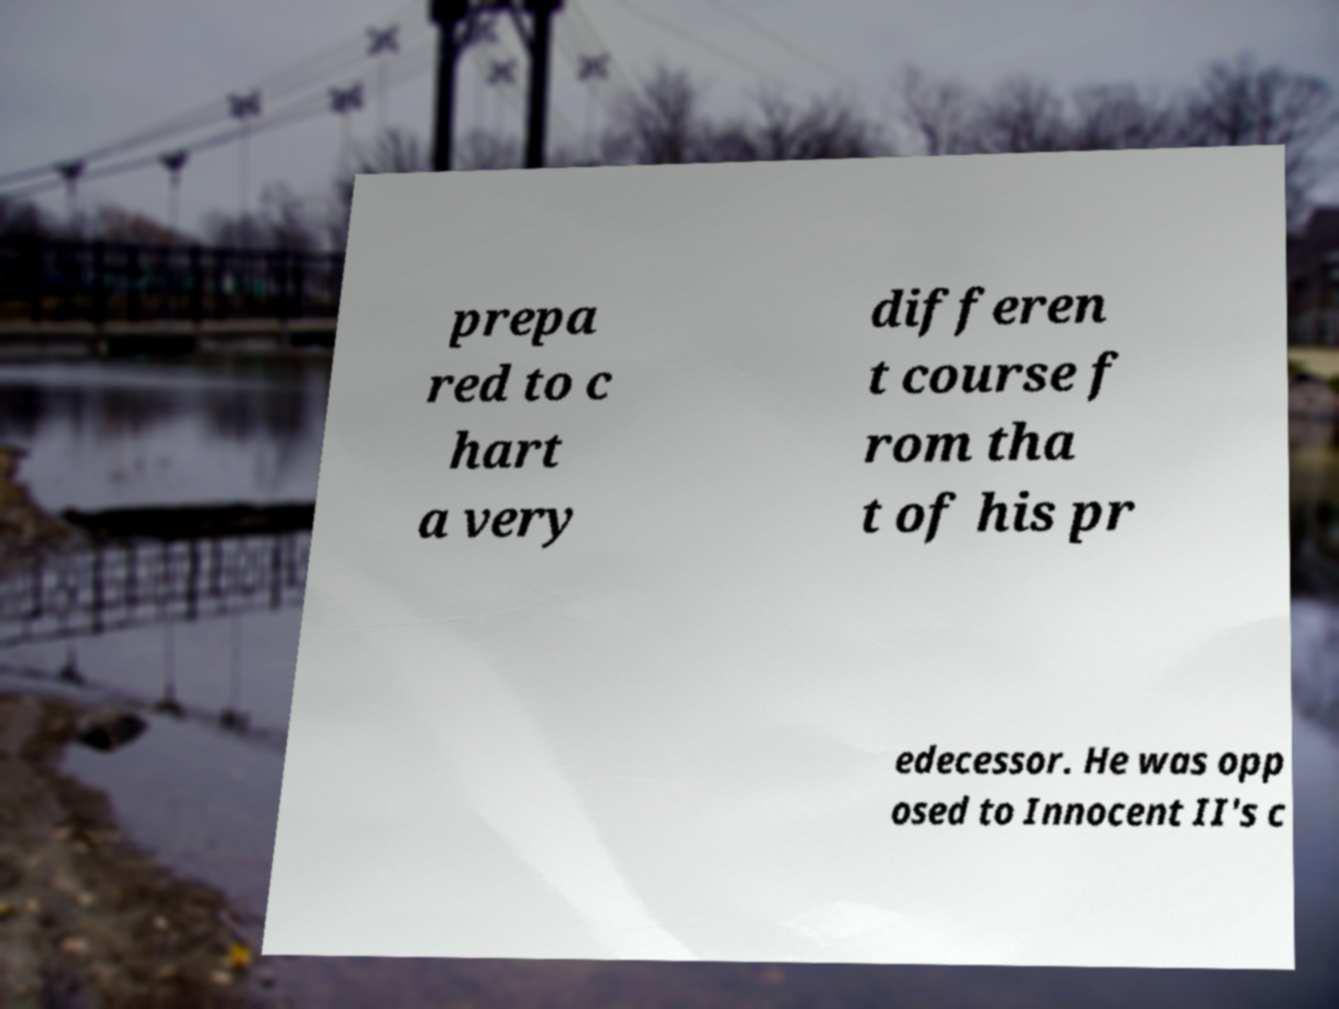Please identify and transcribe the text found in this image. prepa red to c hart a very differen t course f rom tha t of his pr edecessor. He was opp osed to Innocent II's c 